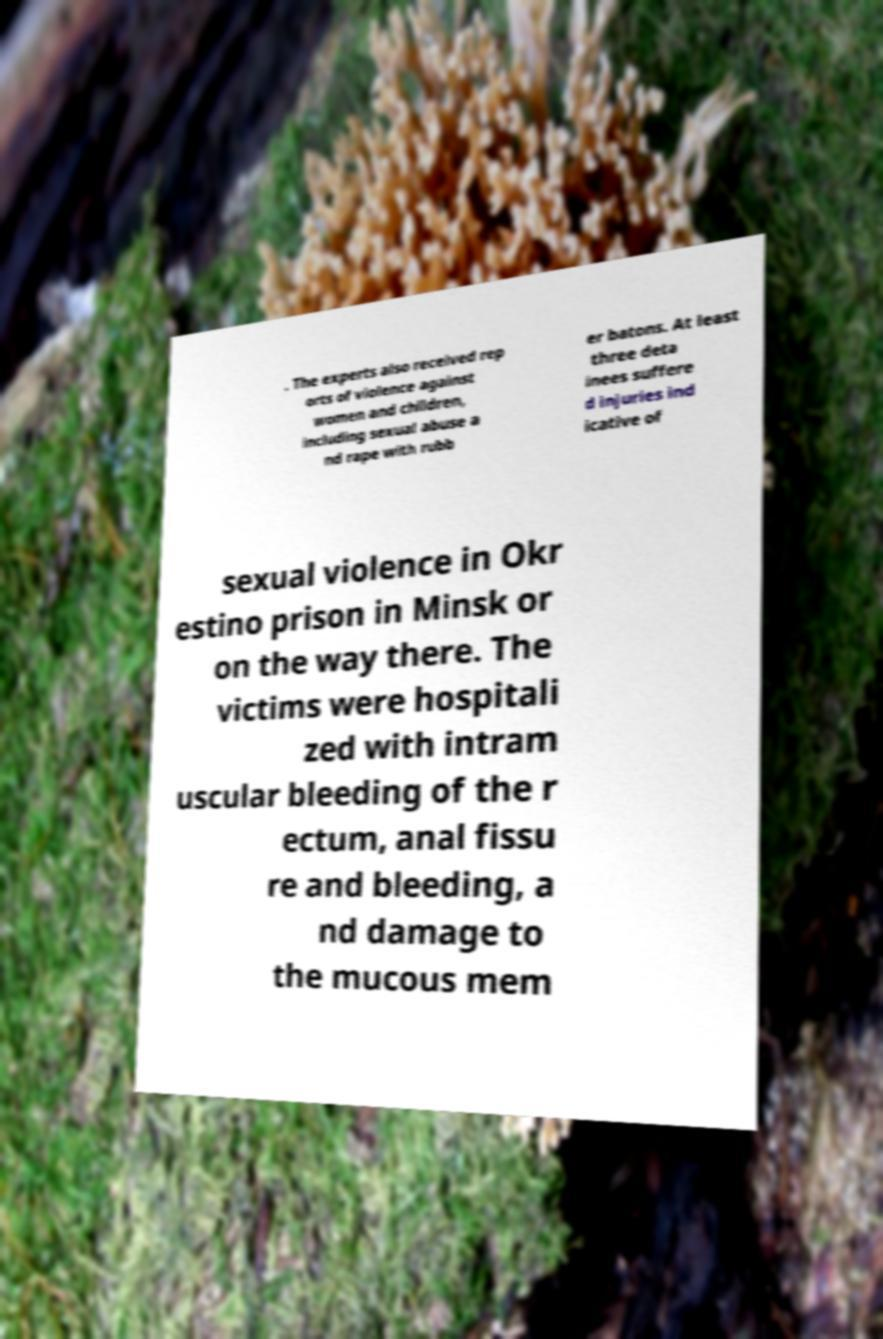There's text embedded in this image that I need extracted. Can you transcribe it verbatim? . The experts also received rep orts of violence against women and children, including sexual abuse a nd rape with rubb er batons. At least three deta inees suffere d injuries ind icative of sexual violence in Okr estino prison in Minsk or on the way there. The victims were hospitali zed with intram uscular bleeding of the r ectum, anal fissu re and bleeding, a nd damage to the mucous mem 